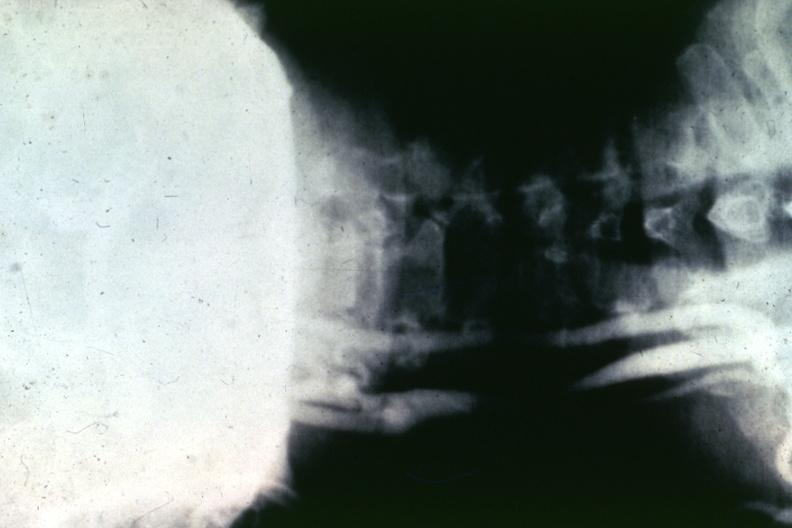s vasculature present?
Answer the question using a single word or phrase. Yes 